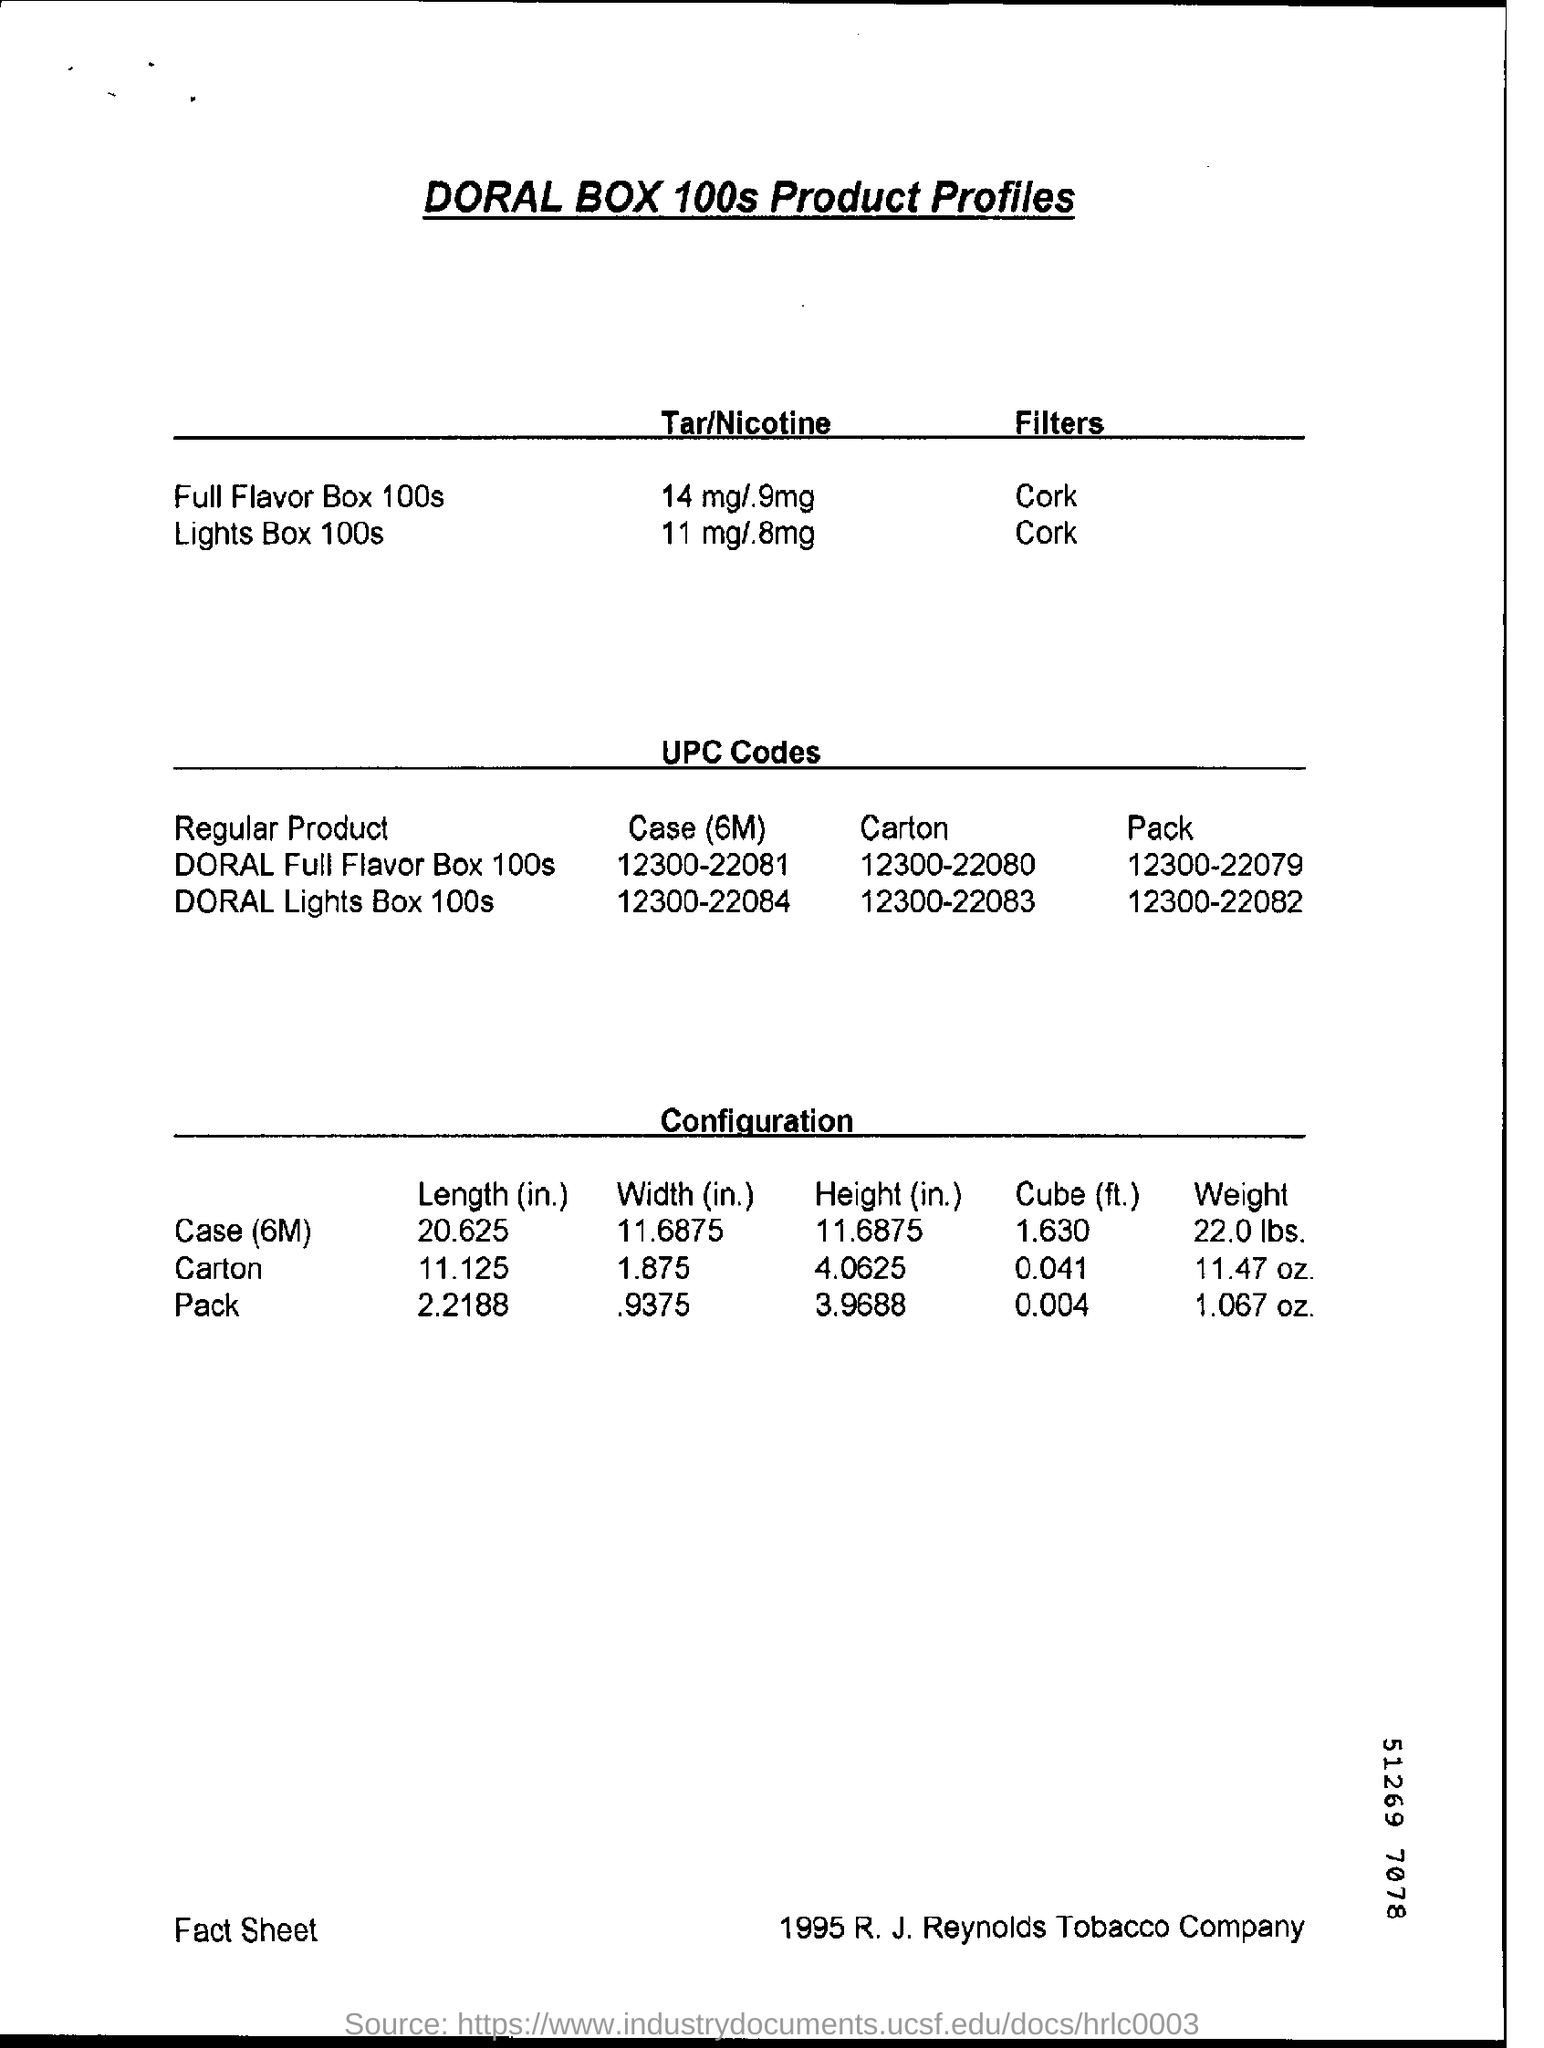What is the tar/nicotine content in Lights Box 100s?
Provide a short and direct response. 11mg/.8mg. What is the UPC Code of DORAL Full Flavour Box 100s Carton?
Ensure brevity in your answer.  12300-22080. What is the weight of a pack?
Give a very brief answer. 1.067 oz. 